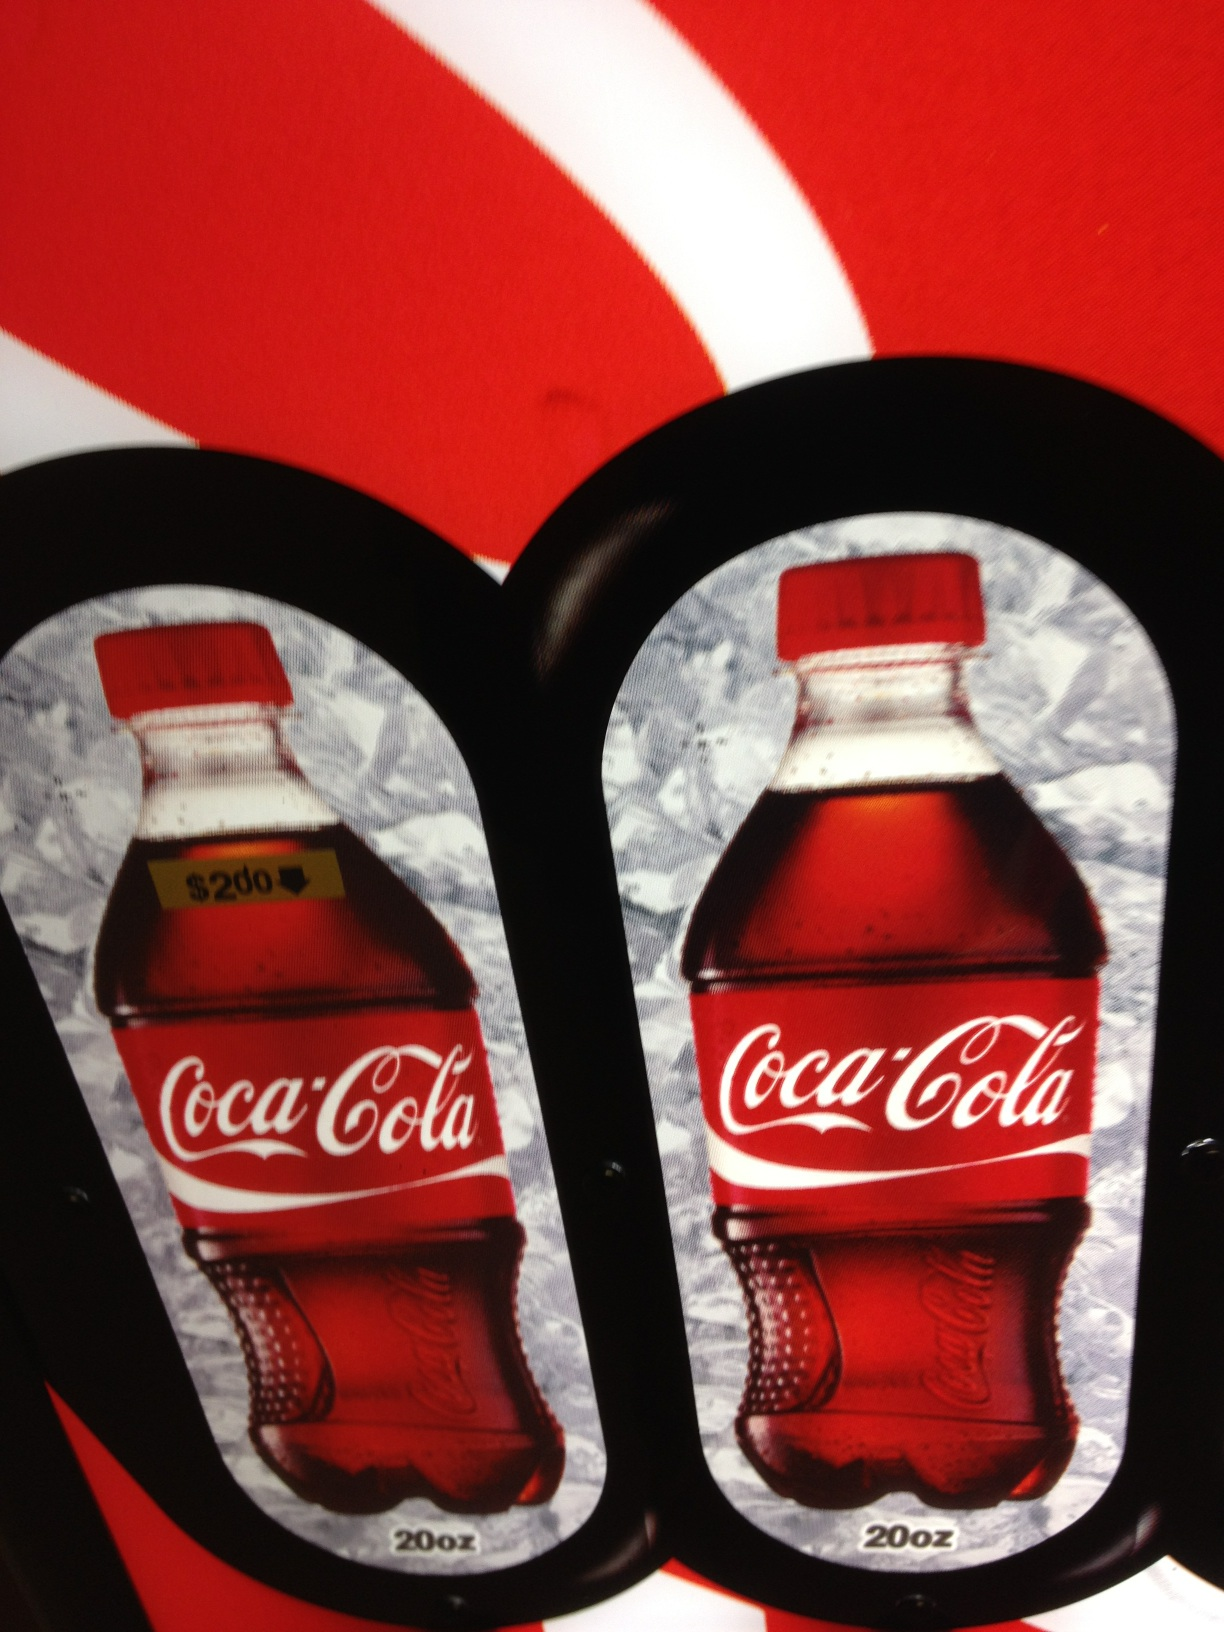Which one is coke zero? The one on the left or the one on the right? The image shows two bottles of Coca-Cola, neither of which is labeled as Coke Zero. Both bottles appear to be regular Coca-Cola, so neither the one on the left nor the one on the right is Coke Zero. 